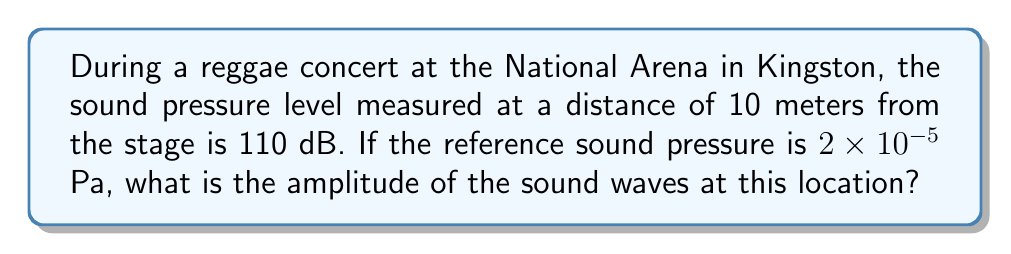Help me with this question. To solve this problem, we'll follow these steps:

1) The sound pressure level (SPL) in decibels is given by the formula:

   $$ SPL = 20 \log_{10} \left(\frac{p_{rms}}{p_{ref}}\right) $$

   Where $p_{rms}$ is the root mean square pressure and $p_{ref}$ is the reference pressure.

2) We're given that SPL = 110 dB and $p_{ref} = 2 \times 10^{-5}$ Pa. Let's substitute these into the equation:

   $$ 110 = 20 \log_{10} \left(\frac{p_{rms}}{2 \times 10^{-5}}\right) $$

3) Solve for $p_{rms}$:
   
   $$ \frac{110}{20} = \log_{10} \left(\frac{p_{rms}}{2 \times 10^{-5}}\right) $$
   
   $$ 5.5 = \log_{10} \left(\frac{p_{rms}}{2 \times 10^{-5}}\right) $$
   
   $$ 10^{5.5} = \frac{p_{rms}}{2 \times 10^{-5}} $$
   
   $$ p_{rms} = 2 \times 10^{-5} \times 10^{5.5} \approx 6.32 \text{ Pa} $$

4) The amplitude (A) of a sine wave is related to its RMS value by:

   $$ A = \sqrt{2} \times p_{rms} $$

5) Therefore, the amplitude of the sound waves is:

   $$ A = \sqrt{2} \times 6.32 \approx 8.94 \text{ Pa} $$
Answer: 8.94 Pa 